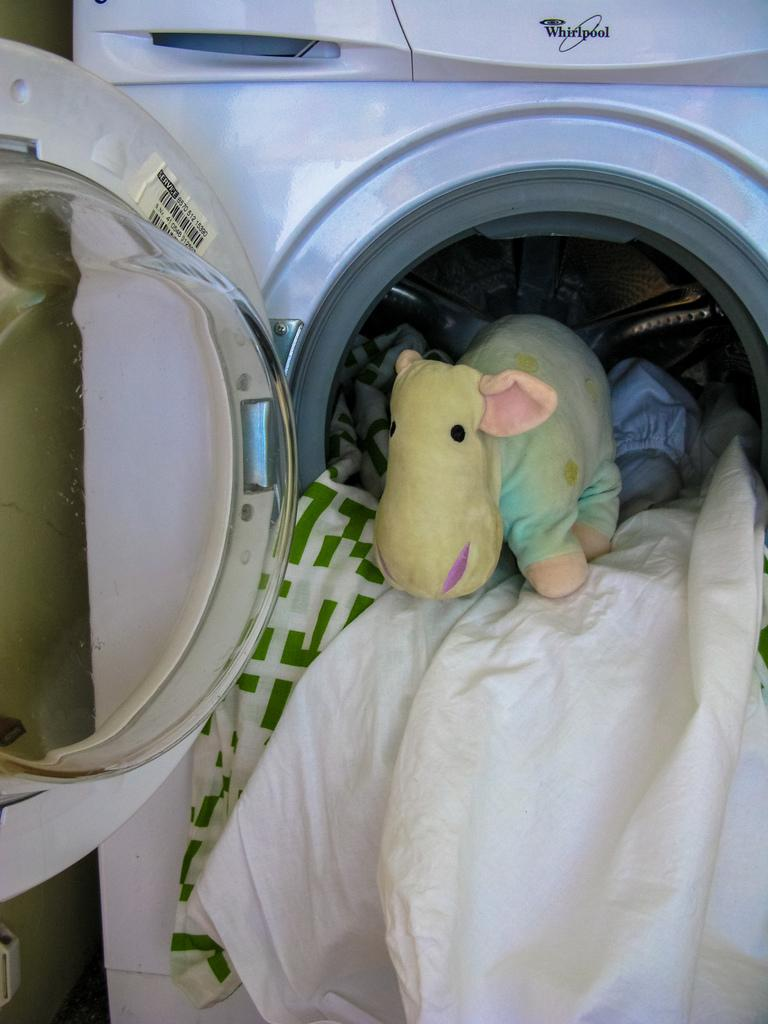What appliance is present in the image? There is a washing machine in the image. What is inside the washing machine? There are clothes and a doll in the washing machine. What type of locket can be seen hanging from the doll's neck in the image? There is no locket visible in the image; the doll is inside the washing machine with clothes. 